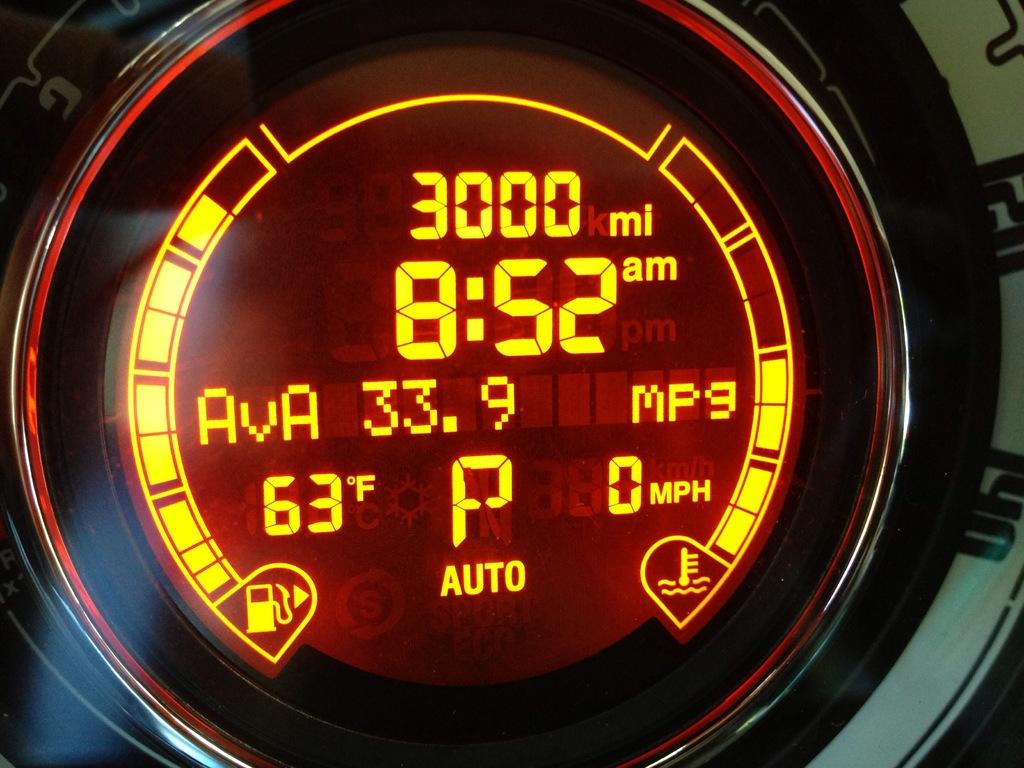Provide a one-sentence caption for the provided image. a dial on  a car dash that says '3000 mi and 8:52' on it. 